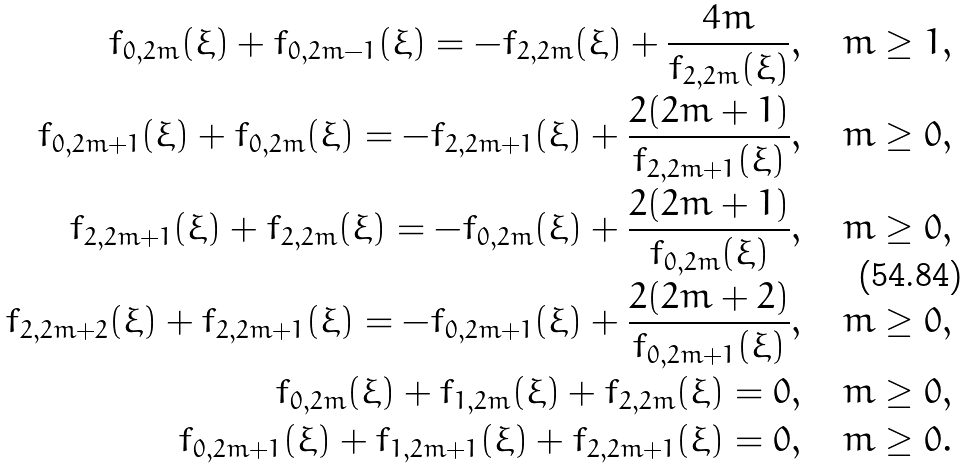<formula> <loc_0><loc_0><loc_500><loc_500>f _ { 0 , 2 m } ( \xi ) + f _ { 0 , 2 m - 1 } ( \xi ) = - f _ { 2 , 2 m } ( \xi ) + \frac { 4 m } { f _ { 2 , 2 m } ( \xi ) } , \quad m \geq 1 , \\ f _ { 0 , 2 m + 1 } ( \xi ) + f _ { 0 , 2 m } ( \xi ) = - f _ { 2 , 2 m + 1 } ( \xi ) + \frac { 2 ( 2 m + 1 ) } { f _ { 2 , 2 m + 1 } ( \xi ) } , \quad m \geq 0 , \\ f _ { 2 , 2 m + 1 } ( \xi ) + f _ { 2 , 2 m } ( \xi ) = - f _ { 0 , 2 m } ( \xi ) + \frac { 2 ( 2 m + 1 ) } { f _ { 0 , 2 m } ( \xi ) } , \quad m \geq 0 , \\ f _ { 2 , 2 m + 2 } ( \xi ) + f _ { 2 , 2 m + 1 } ( \xi ) = - f _ { 0 , 2 m + 1 } ( \xi ) + \frac { 2 ( 2 m + 2 ) } { f _ { 0 , 2 m + 1 } ( \xi ) } , \quad m \geq 0 , \\ f _ { 0 , 2 m } ( \xi ) + f _ { 1 , 2 m } ( \xi ) + f _ { 2 , 2 m } ( \xi ) = 0 , \quad m \geq 0 , \\ f _ { 0 , 2 m + 1 } ( \xi ) + f _ { 1 , 2 m + 1 } ( \xi ) + f _ { 2 , 2 m + 1 } ( \xi ) = 0 , \quad m \geq 0 .</formula> 